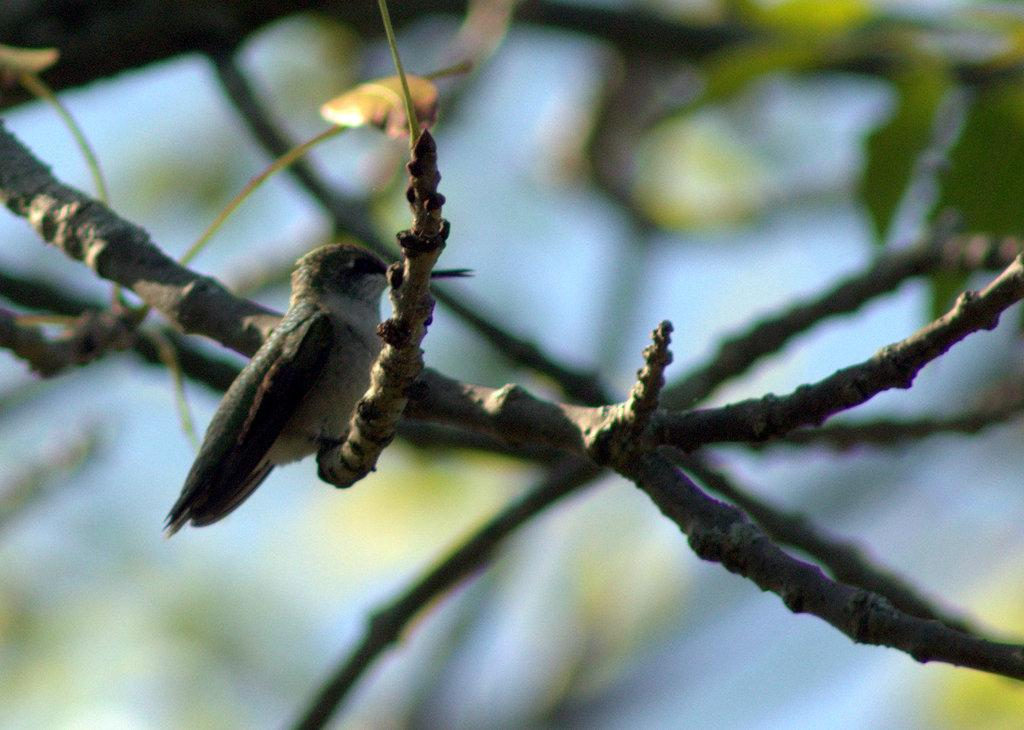What type of animal can be seen in the image? There is a bird in the image. Where is the bird located in the image? The bird is sitting on a tree. What type of hat is the fireman wearing in the image? There is no fireman present in the image; it features a bird sitting on a tree. Is the bird holding an umbrella in the image? There is no umbrella present in the image; it features a bird sitting on a tree. 